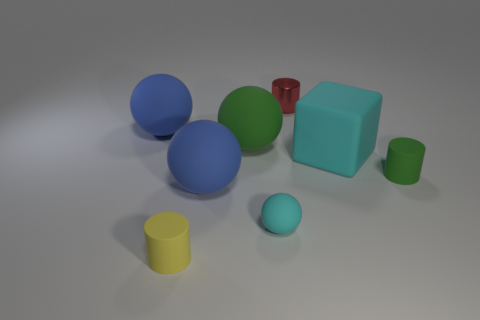How many objects in the image are round? There are four round objects in the image, consisting of two larger spheres and two smaller ones. 